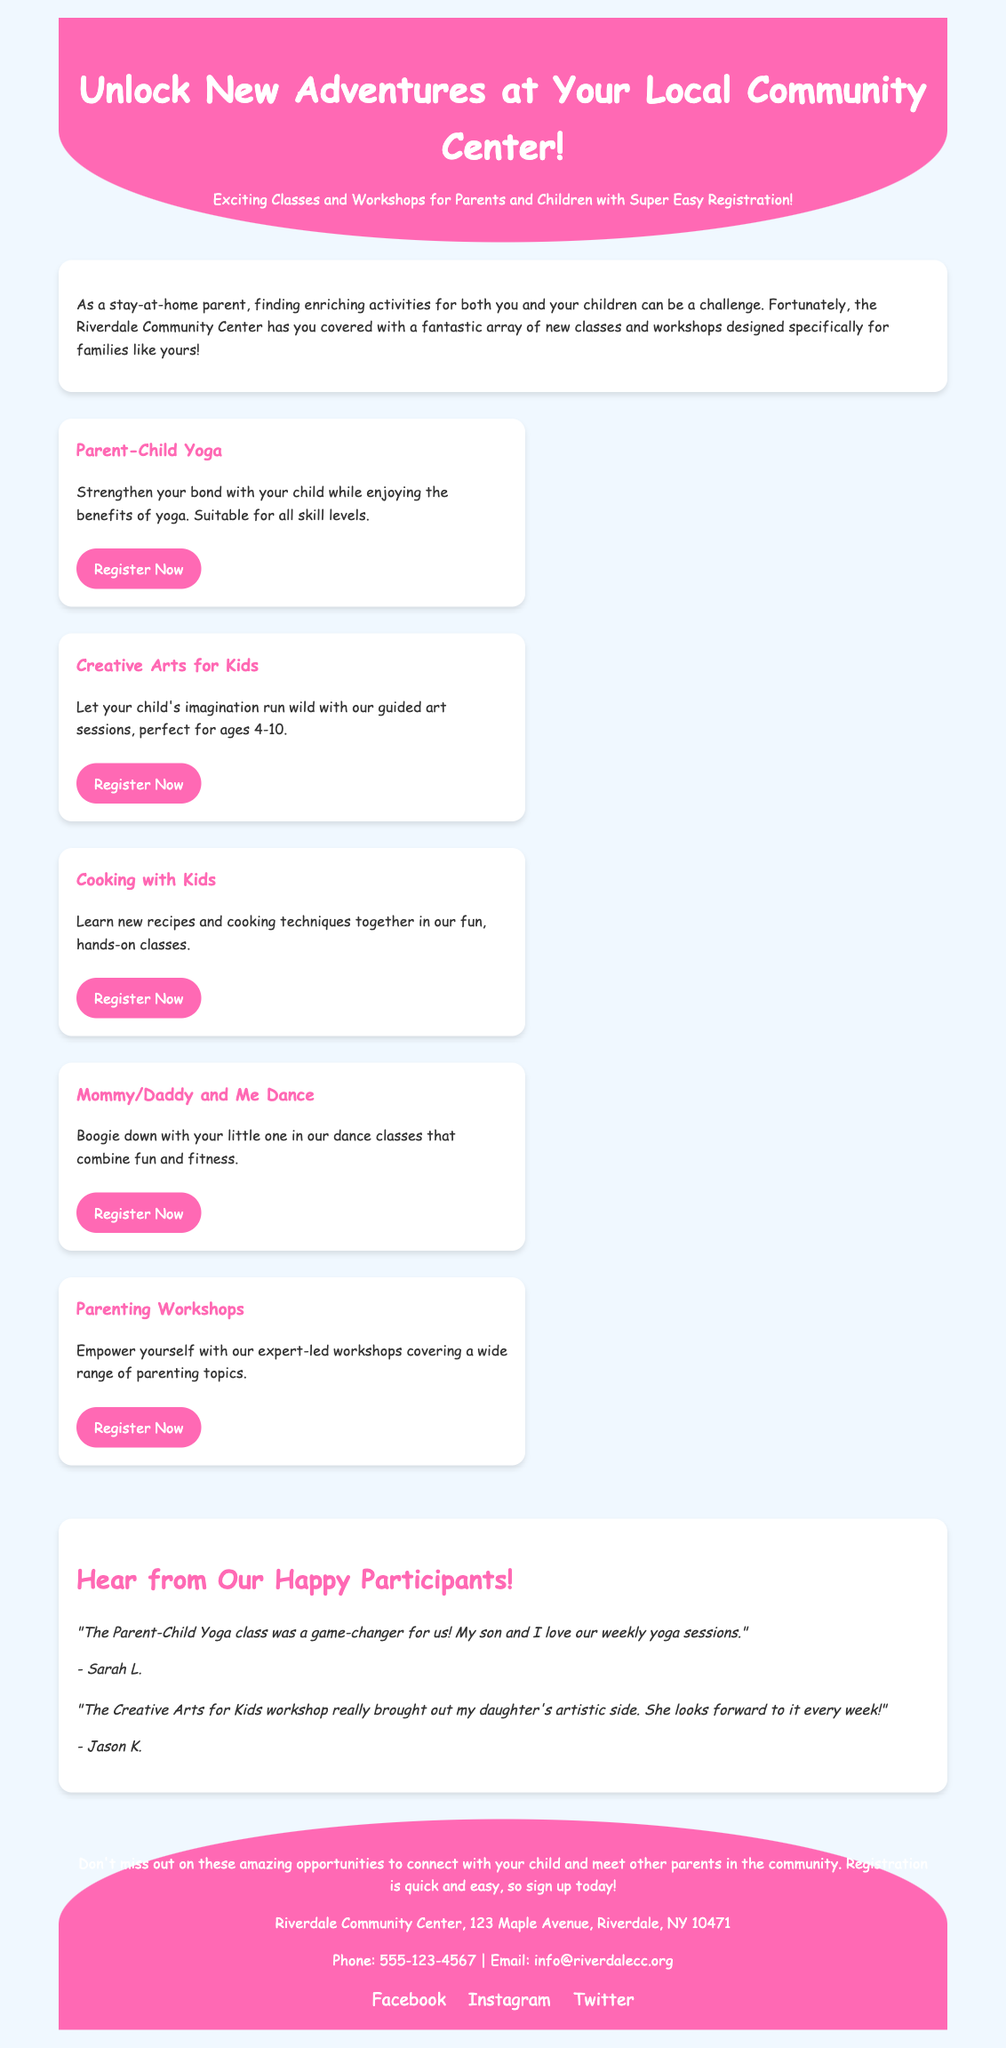What is the title of the advertisement? The title of the advertisement is displayed prominently at the top, inviting readers to unlock new adventures.
Answer: Unlock New Adventures at Your Local Community Center! What classes are offered for parents and children? The advertisement lists classes like Parent-Child Yoga, Creative Arts for Kids, Cooking with Kids, Mommy/Daddy and Me Dance, and Parenting Workshops.
Answer: Parent-Child Yoga, Creative Arts for Kids, Cooking with Kids, Mommy/Daddy and Me Dance, Parenting Workshops What is the age range for the Creative Arts for Kids workshop? The age range for this class is provided in the description, specifying it is for children aged 4-10.
Answer: 4-10 Who provided a testimonial about the Parent-Child Yoga class? The testimonial section credits Sarah L. for her positive feedback about the Parent-Child Yoga class experience.
Answer: Sarah L How many classes or workshops are listed in total? The advertisement clearly outlines five different classes offered for parents and children, counting them gives us the total.
Answer: 5 What is the primary benefit of the Parenting Workshops? The advertisement specifies that these workshops are led by experts and cover a wide range of parenting topics.
Answer: Empowerment through expert-led workshops What is the registration link for the Cooking with Kids class? The advertisement provides a specific URL for the Cooking with Kids class, which can be found in the relevant section.
Answer: http://www.riverdalecc.org/cooking What is the background color of the webpage? The advertisement describes the overall webpage color scheme, mentioning a light blue tone as the background color.
Answer: Light blue 